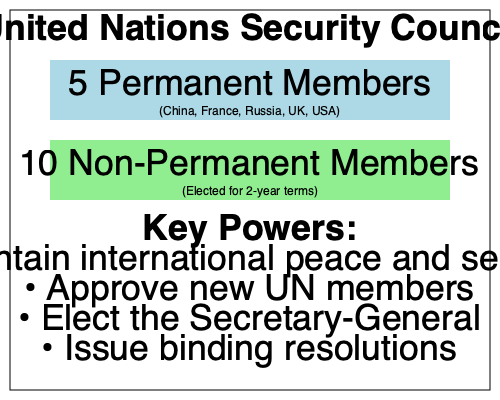As a debating champion with expertise in national security, analyze the structure of the UN Security Council shown in the organizational chart. What unique power do the 5 permanent members possess that significantly impacts the Council's decision-making process, and how might this affect global counter-terrorism efforts? To answer this question, let's break down the structure and powers of the UN Security Council:

1. Composition:
   - 5 Permanent Members: China, France, Russia, UK, USA
   - 10 Non-Permanent Members: Elected for 2-year terms

2. Key Powers of the Security Council:
   - Maintain international peace and security
   - Approve new UN members
   - Elect the Secretary-General
   - Issue binding resolutions

3. Unique power of Permanent Members:
   The 5 permanent members possess veto power. This means they can block any substantive resolution, regardless of its level of international support.

4. Impact on decision-making:
   - Any permanent member can unilaterally prevent the adoption of a resolution.
   - This gives these five nations significant influence over global security matters.

5. Effect on counter-terrorism efforts:
   - Veto power can hinder swift and decisive action against terrorist threats.
   - If a permanent member disagrees with a proposed counter-terrorism measure, they can block it.
   - This may lead to delays or compromises in international responses to terrorism.
   - It can also result in geopolitical considerations influencing counter-terrorism strategies.

6. Debate considerations:
   - The veto power ensures that major world powers remain engaged in the UN system.
   - However, it can also lead to deadlock on critical issues if permanent members have conflicting interests.
   - This structure reflects post-World War II power dynamics, which may not accurately represent current global realities.

The unique power that significantly impacts the Council's decision-making process is the veto power, which can both strengthen and complicate global counter-terrorism efforts depending on the alignment of interests among the permanent members.
Answer: Veto power 